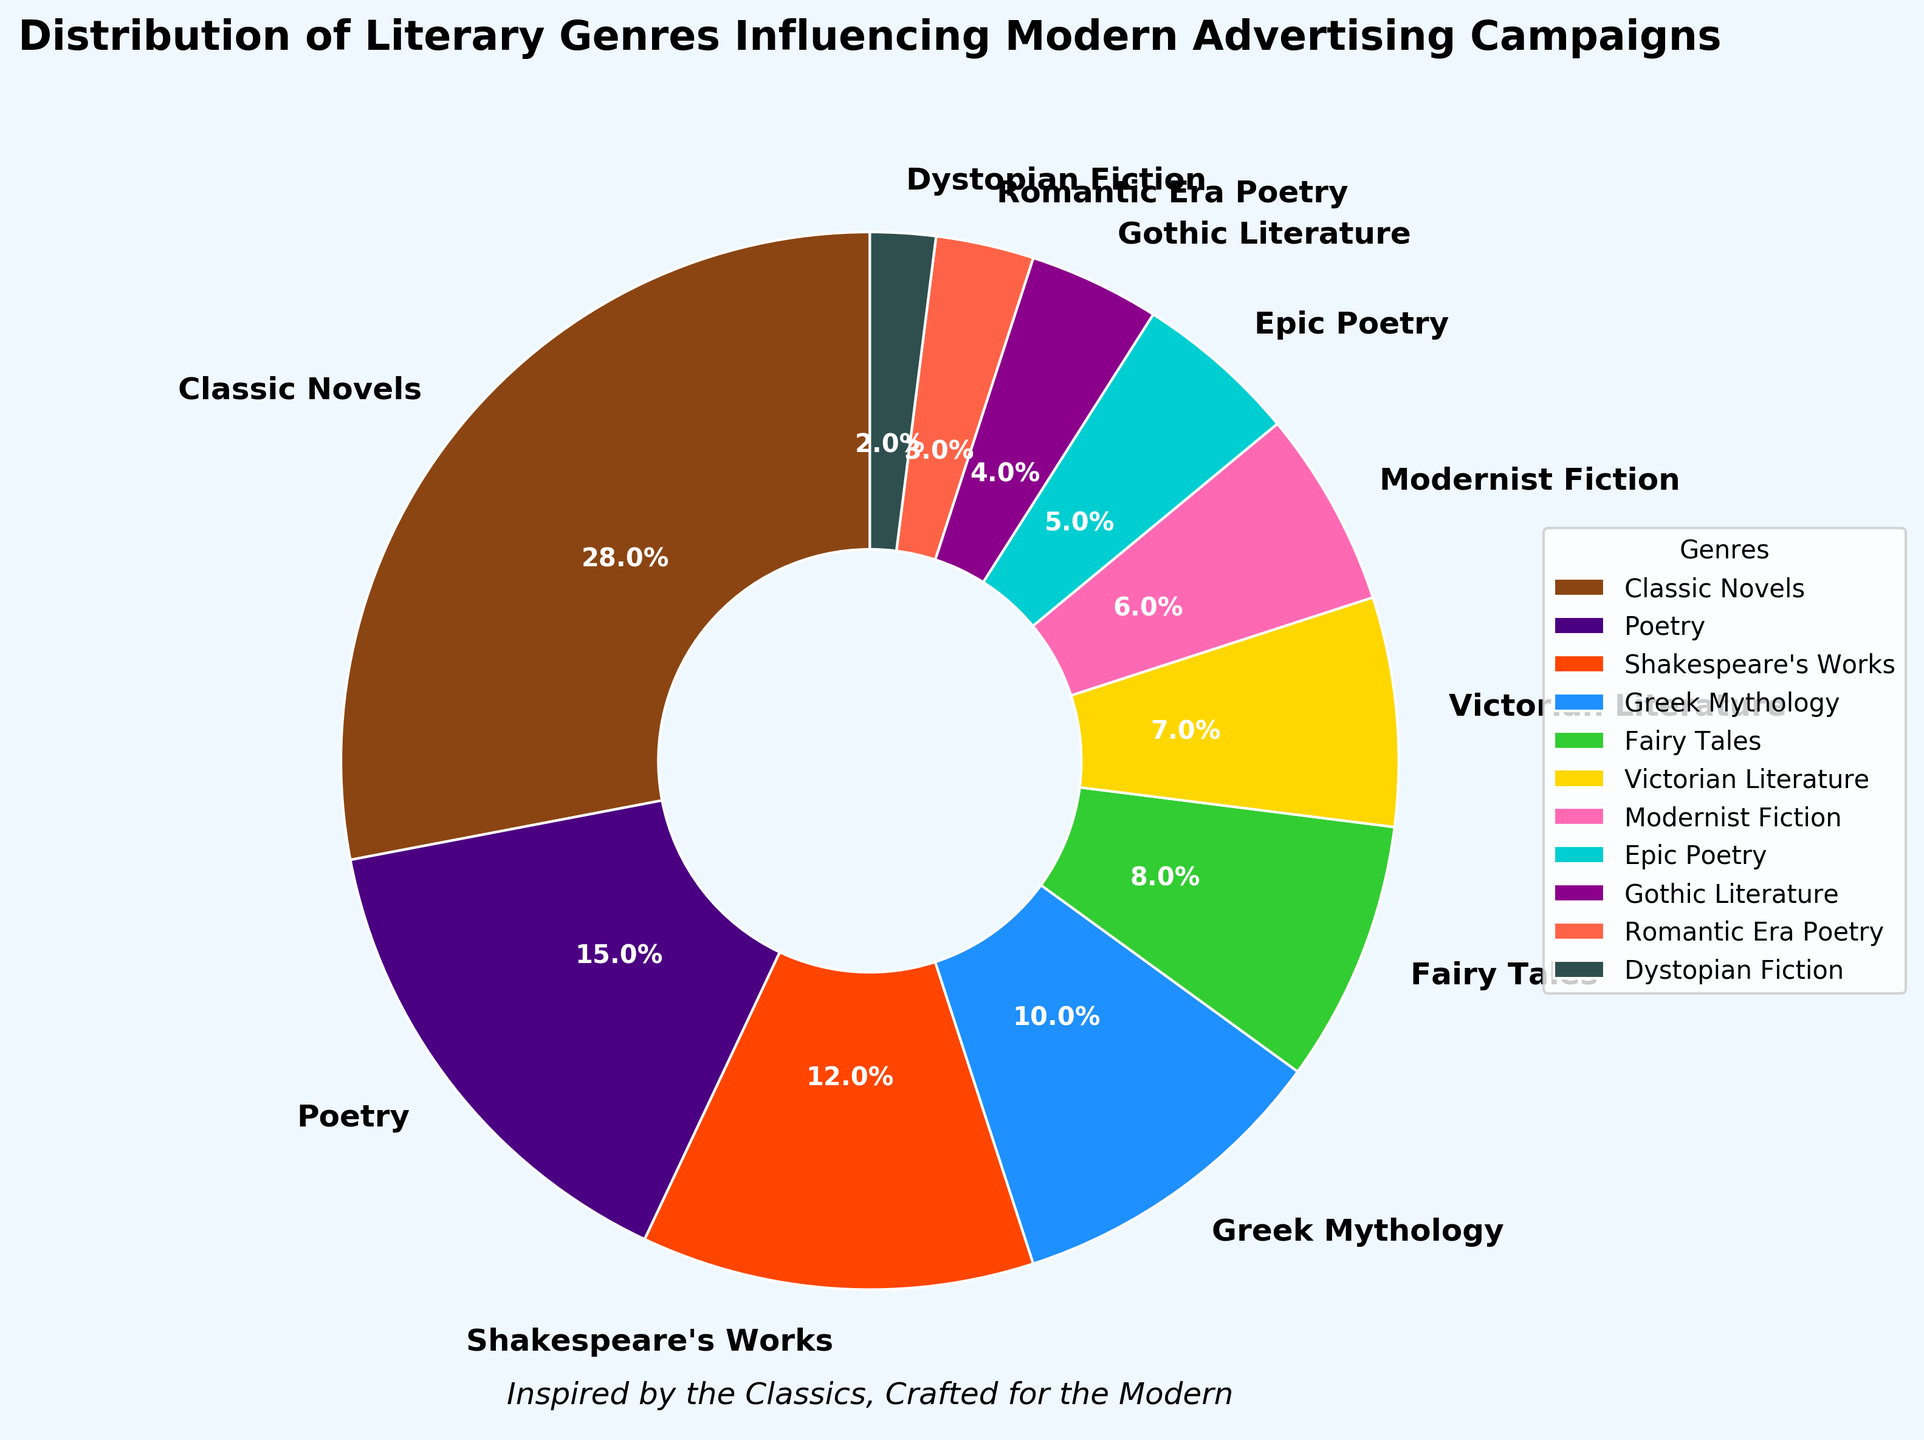What's the total percentage of literary genres derived from mythological or ancient sources? Combine the percentages of Greek Mythology (10%) and Epic Poetry (5%). Thus, the total percentage is 10 + 5 = 15%.
Answer: 15% Which genre is more influential in modern advertising campaigns: Victorian Literature or Modernist Fiction? Compare the percentages: Victorian Literature (7%) vs. Modernist Fiction (6%). Victorian Literature has a higher percentage than Modernist Fiction.
Answer: Victorian Literature Which genre has the smallest influence on modern advertising campaigns? Identify the genre with the lowest percentage. Dystopian Fiction has the smallest influence with 2%.
Answer: Dystopian Fiction How much more influential are Classic Novels compared to Gothic Literature? Find the difference in their percentages: Classic Novels (28%) - Gothic Literature (4%) = 24%. Thus, Classic Novels are 24% more influential.
Answer: 24% Calculate the combined influence of Classical Novels, Shakespeare's Works, and Poetry. Add the percentages of Classic Novels (28%), Shakespeare's Works (12%), and Poetry (15%). The combined influence is 28 + 12 + 15 = 55%.
Answer: 55% What is the difference in influence between Fairy Tales and Epic Poetry? Compare their percentages: Fairy Tales (8%) and Epic Poetry (5%). The difference is 8 - 5 = 3%.
Answer: 3% Are the combined percentages of genres categorized as poetry greater than or less than the percentage of Classic Novels? Add the percentages of Poetry (15%) and Romantic Era Poetry (3%), which is 15 + 3 = 18%, and compare it to Classic Novels (28%). The combined percentage of poetry (18%) is less than Classic Novels (28%).
Answer: Less than Which single genre’s influence percentage is equivalent to the sum of Modernist Fiction and Fairy Tales? Add the percentages of Modernist Fiction (6%) and Fairy Tales (8%), which equals 6 + 8 = 14%. This total matches no single genre’s percentage exactly.
Answer: None Identify the genre represented with the color dark blue in the pie chart. Understanding the specific colors assigned visually, dark blue is used for Greek Mythology.
Answer: Greek Mythology 